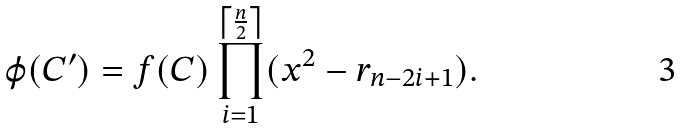<formula> <loc_0><loc_0><loc_500><loc_500>\varphi ( C ^ { \prime } ) = f ( C ) \prod _ { i = 1 } ^ { \left \lceil \frac { n } { 2 } \right \rceil } ( x ^ { 2 } - r _ { n - 2 i + 1 } ) .</formula> 